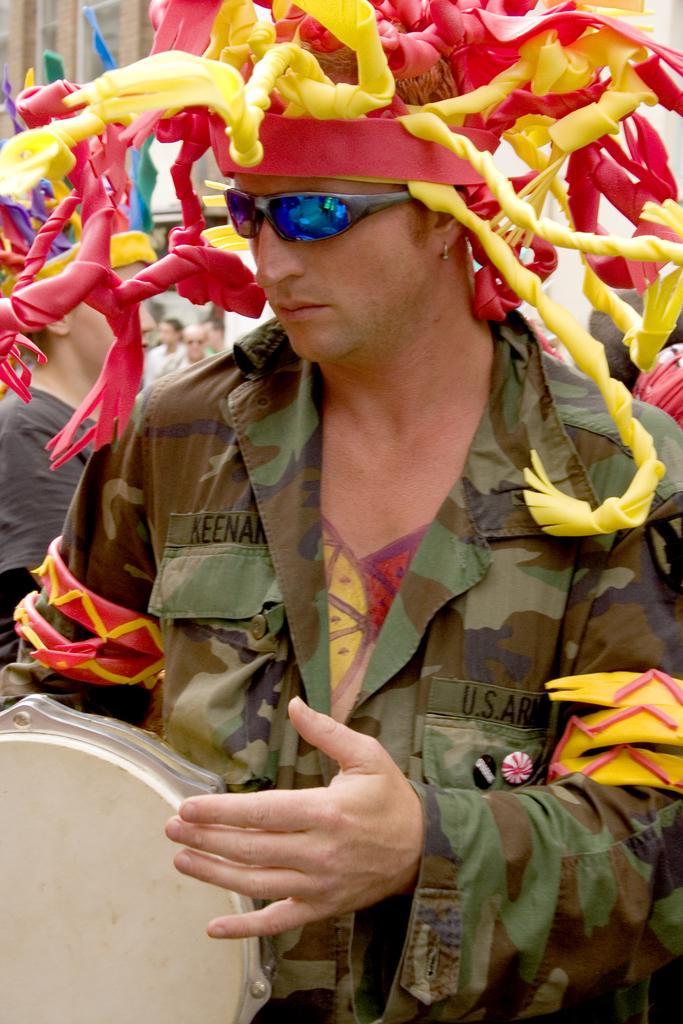Can you describe this image briefly? In this image we can see a man. He is wearing a hat and playing a musical instrument. In the background, we can see people and a building. 